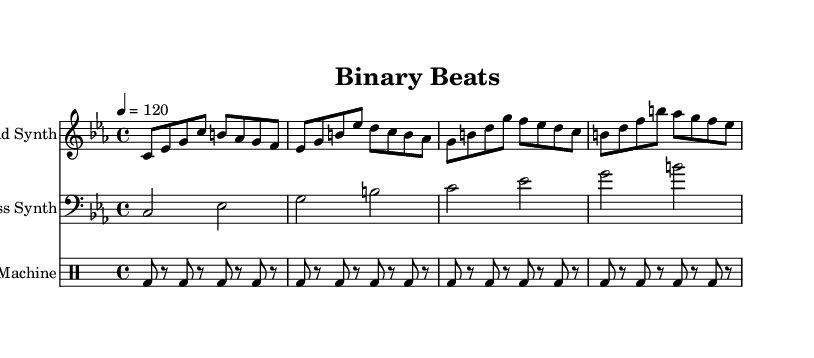What is the key signature of this music? The key signature is indicated at the beginning of the score. It shows 3 flats, meaning the key is C minor.
Answer: C minor What is the time signature of this music? The time signature is shown right after the key signature, which is 4/4, meaning there are four beats in a measure.
Answer: 4/4 What is the tempo marking of this music? The tempo marking is indicated at the beginning, which states "4 = 120," meaning there are 120 beats per minute in quarter note values.
Answer: 120 How many measures are in the lead synth part? We count the individual groups of notes, separated by vertical lines, in the lead synth part. There are four measures present.
Answer: 4 Which instrument has a bass clef in the score? The bass synth part is written using the bass clef, typically indicating lower pitches compared to the treble clef used by the lead synth.
Answer: Bass Synth How often does the bass synth play in relation to the lead synth? Observing the score, the bass synth plays every two beats, while the lead synth has more notes and is constant throughout. This means that the bass synth interjects every measure compared to the lead synth.
Answer: Every two beats What type of rhythm does the drum machine employ? The drum machine part consistently uses a bass drum pattern that consists of alternating hits and rests, typically following a digging or driving rhythm common in electronic music.
Answer: Alternating hits and rests 